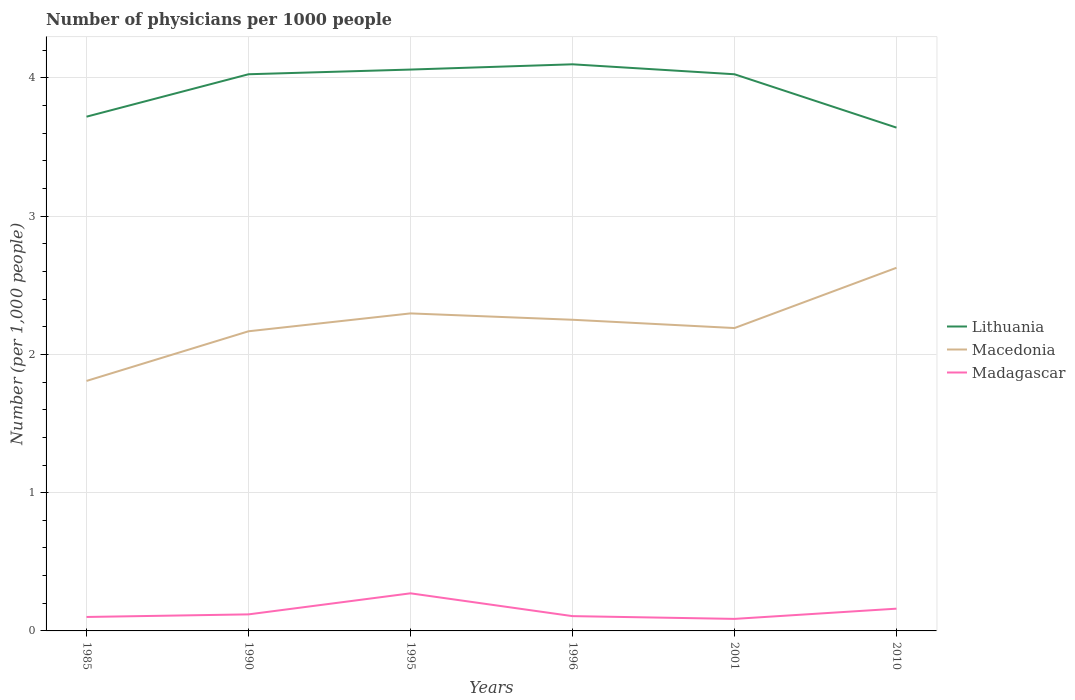Is the number of lines equal to the number of legend labels?
Ensure brevity in your answer.  Yes. Across all years, what is the maximum number of physicians in Macedonia?
Ensure brevity in your answer.  1.81. In which year was the number of physicians in Lithuania maximum?
Provide a succinct answer. 2010. What is the total number of physicians in Lithuania in the graph?
Give a very brief answer. -0.07. What is the difference between the highest and the second highest number of physicians in Macedonia?
Provide a short and direct response. 0.82. What is the difference between two consecutive major ticks on the Y-axis?
Your response must be concise. 1. Are the values on the major ticks of Y-axis written in scientific E-notation?
Your response must be concise. No. Does the graph contain grids?
Ensure brevity in your answer.  Yes. Where does the legend appear in the graph?
Your answer should be very brief. Center right. What is the title of the graph?
Your answer should be compact. Number of physicians per 1000 people. What is the label or title of the Y-axis?
Keep it short and to the point. Number (per 1,0 people). What is the Number (per 1,000 people) in Lithuania in 1985?
Offer a very short reply. 3.72. What is the Number (per 1,000 people) in Macedonia in 1985?
Provide a short and direct response. 1.81. What is the Number (per 1,000 people) in Madagascar in 1985?
Keep it short and to the point. 0.1. What is the Number (per 1,000 people) in Lithuania in 1990?
Make the answer very short. 4.03. What is the Number (per 1,000 people) in Macedonia in 1990?
Ensure brevity in your answer.  2.17. What is the Number (per 1,000 people) of Madagascar in 1990?
Keep it short and to the point. 0.12. What is the Number (per 1,000 people) of Lithuania in 1995?
Offer a terse response. 4.06. What is the Number (per 1,000 people) in Macedonia in 1995?
Your answer should be very brief. 2.3. What is the Number (per 1,000 people) in Madagascar in 1995?
Offer a very short reply. 0.27. What is the Number (per 1,000 people) in Lithuania in 1996?
Make the answer very short. 4.1. What is the Number (per 1,000 people) in Macedonia in 1996?
Give a very brief answer. 2.25. What is the Number (per 1,000 people) of Madagascar in 1996?
Offer a terse response. 0.11. What is the Number (per 1,000 people) of Lithuania in 2001?
Give a very brief answer. 4.03. What is the Number (per 1,000 people) of Macedonia in 2001?
Your answer should be compact. 2.19. What is the Number (per 1,000 people) of Madagascar in 2001?
Keep it short and to the point. 0.09. What is the Number (per 1,000 people) in Lithuania in 2010?
Keep it short and to the point. 3.64. What is the Number (per 1,000 people) in Macedonia in 2010?
Your response must be concise. 2.63. What is the Number (per 1,000 people) in Madagascar in 2010?
Keep it short and to the point. 0.16. Across all years, what is the maximum Number (per 1,000 people) of Lithuania?
Make the answer very short. 4.1. Across all years, what is the maximum Number (per 1,000 people) in Macedonia?
Make the answer very short. 2.63. Across all years, what is the maximum Number (per 1,000 people) in Madagascar?
Offer a very short reply. 0.27. Across all years, what is the minimum Number (per 1,000 people) of Lithuania?
Ensure brevity in your answer.  3.64. Across all years, what is the minimum Number (per 1,000 people) of Macedonia?
Your response must be concise. 1.81. Across all years, what is the minimum Number (per 1,000 people) of Madagascar?
Keep it short and to the point. 0.09. What is the total Number (per 1,000 people) in Lithuania in the graph?
Your response must be concise. 23.58. What is the total Number (per 1,000 people) of Macedonia in the graph?
Your answer should be very brief. 13.34. What is the total Number (per 1,000 people) of Madagascar in the graph?
Your answer should be very brief. 0.85. What is the difference between the Number (per 1,000 people) of Lithuania in 1985 and that in 1990?
Your answer should be very brief. -0.31. What is the difference between the Number (per 1,000 people) of Macedonia in 1985 and that in 1990?
Offer a terse response. -0.36. What is the difference between the Number (per 1,000 people) of Madagascar in 1985 and that in 1990?
Provide a succinct answer. -0.02. What is the difference between the Number (per 1,000 people) in Lithuania in 1985 and that in 1995?
Make the answer very short. -0.34. What is the difference between the Number (per 1,000 people) of Macedonia in 1985 and that in 1995?
Provide a short and direct response. -0.49. What is the difference between the Number (per 1,000 people) in Madagascar in 1985 and that in 1995?
Ensure brevity in your answer.  -0.17. What is the difference between the Number (per 1,000 people) of Lithuania in 1985 and that in 1996?
Ensure brevity in your answer.  -0.38. What is the difference between the Number (per 1,000 people) of Macedonia in 1985 and that in 1996?
Your response must be concise. -0.44. What is the difference between the Number (per 1,000 people) of Madagascar in 1985 and that in 1996?
Give a very brief answer. -0.01. What is the difference between the Number (per 1,000 people) in Lithuania in 1985 and that in 2001?
Your answer should be compact. -0.31. What is the difference between the Number (per 1,000 people) of Macedonia in 1985 and that in 2001?
Your answer should be compact. -0.38. What is the difference between the Number (per 1,000 people) of Madagascar in 1985 and that in 2001?
Your answer should be compact. 0.01. What is the difference between the Number (per 1,000 people) in Lithuania in 1985 and that in 2010?
Make the answer very short. 0.08. What is the difference between the Number (per 1,000 people) of Macedonia in 1985 and that in 2010?
Your answer should be compact. -0.82. What is the difference between the Number (per 1,000 people) of Madagascar in 1985 and that in 2010?
Ensure brevity in your answer.  -0.06. What is the difference between the Number (per 1,000 people) in Lithuania in 1990 and that in 1995?
Ensure brevity in your answer.  -0.03. What is the difference between the Number (per 1,000 people) of Macedonia in 1990 and that in 1995?
Ensure brevity in your answer.  -0.13. What is the difference between the Number (per 1,000 people) in Madagascar in 1990 and that in 1995?
Make the answer very short. -0.15. What is the difference between the Number (per 1,000 people) in Lithuania in 1990 and that in 1996?
Offer a very short reply. -0.07. What is the difference between the Number (per 1,000 people) in Macedonia in 1990 and that in 1996?
Offer a terse response. -0.08. What is the difference between the Number (per 1,000 people) in Madagascar in 1990 and that in 1996?
Your answer should be compact. 0.01. What is the difference between the Number (per 1,000 people) of Macedonia in 1990 and that in 2001?
Keep it short and to the point. -0.02. What is the difference between the Number (per 1,000 people) in Madagascar in 1990 and that in 2001?
Provide a short and direct response. 0.03. What is the difference between the Number (per 1,000 people) in Lithuania in 1990 and that in 2010?
Your answer should be very brief. 0.39. What is the difference between the Number (per 1,000 people) of Macedonia in 1990 and that in 2010?
Your answer should be compact. -0.46. What is the difference between the Number (per 1,000 people) of Madagascar in 1990 and that in 2010?
Give a very brief answer. -0.04. What is the difference between the Number (per 1,000 people) in Lithuania in 1995 and that in 1996?
Keep it short and to the point. -0.04. What is the difference between the Number (per 1,000 people) of Macedonia in 1995 and that in 1996?
Make the answer very short. 0.05. What is the difference between the Number (per 1,000 people) in Madagascar in 1995 and that in 1996?
Keep it short and to the point. 0.17. What is the difference between the Number (per 1,000 people) in Lithuania in 1995 and that in 2001?
Offer a very short reply. 0.03. What is the difference between the Number (per 1,000 people) in Macedonia in 1995 and that in 2001?
Make the answer very short. 0.11. What is the difference between the Number (per 1,000 people) in Madagascar in 1995 and that in 2001?
Make the answer very short. 0.18. What is the difference between the Number (per 1,000 people) in Lithuania in 1995 and that in 2010?
Give a very brief answer. 0.42. What is the difference between the Number (per 1,000 people) of Macedonia in 1995 and that in 2010?
Keep it short and to the point. -0.33. What is the difference between the Number (per 1,000 people) in Madagascar in 1995 and that in 2010?
Make the answer very short. 0.11. What is the difference between the Number (per 1,000 people) of Lithuania in 1996 and that in 2001?
Make the answer very short. 0.07. What is the difference between the Number (per 1,000 people) of Macedonia in 1996 and that in 2001?
Ensure brevity in your answer.  0.06. What is the difference between the Number (per 1,000 people) in Lithuania in 1996 and that in 2010?
Your answer should be compact. 0.46. What is the difference between the Number (per 1,000 people) of Macedonia in 1996 and that in 2010?
Offer a terse response. -0.38. What is the difference between the Number (per 1,000 people) in Madagascar in 1996 and that in 2010?
Offer a terse response. -0.05. What is the difference between the Number (per 1,000 people) in Lithuania in 2001 and that in 2010?
Give a very brief answer. 0.39. What is the difference between the Number (per 1,000 people) in Macedonia in 2001 and that in 2010?
Give a very brief answer. -0.44. What is the difference between the Number (per 1,000 people) in Madagascar in 2001 and that in 2010?
Ensure brevity in your answer.  -0.07. What is the difference between the Number (per 1,000 people) in Lithuania in 1985 and the Number (per 1,000 people) in Macedonia in 1990?
Provide a succinct answer. 1.55. What is the difference between the Number (per 1,000 people) of Lithuania in 1985 and the Number (per 1,000 people) of Madagascar in 1990?
Ensure brevity in your answer.  3.6. What is the difference between the Number (per 1,000 people) of Macedonia in 1985 and the Number (per 1,000 people) of Madagascar in 1990?
Provide a succinct answer. 1.69. What is the difference between the Number (per 1,000 people) of Lithuania in 1985 and the Number (per 1,000 people) of Macedonia in 1995?
Provide a succinct answer. 1.42. What is the difference between the Number (per 1,000 people) of Lithuania in 1985 and the Number (per 1,000 people) of Madagascar in 1995?
Your response must be concise. 3.45. What is the difference between the Number (per 1,000 people) of Macedonia in 1985 and the Number (per 1,000 people) of Madagascar in 1995?
Your answer should be very brief. 1.54. What is the difference between the Number (per 1,000 people) of Lithuania in 1985 and the Number (per 1,000 people) of Macedonia in 1996?
Ensure brevity in your answer.  1.47. What is the difference between the Number (per 1,000 people) in Lithuania in 1985 and the Number (per 1,000 people) in Madagascar in 1996?
Keep it short and to the point. 3.61. What is the difference between the Number (per 1,000 people) in Macedonia in 1985 and the Number (per 1,000 people) in Madagascar in 1996?
Give a very brief answer. 1.7. What is the difference between the Number (per 1,000 people) of Lithuania in 1985 and the Number (per 1,000 people) of Macedonia in 2001?
Offer a very short reply. 1.53. What is the difference between the Number (per 1,000 people) of Lithuania in 1985 and the Number (per 1,000 people) of Madagascar in 2001?
Make the answer very short. 3.63. What is the difference between the Number (per 1,000 people) in Macedonia in 1985 and the Number (per 1,000 people) in Madagascar in 2001?
Offer a very short reply. 1.72. What is the difference between the Number (per 1,000 people) in Lithuania in 1985 and the Number (per 1,000 people) in Macedonia in 2010?
Your response must be concise. 1.09. What is the difference between the Number (per 1,000 people) in Lithuania in 1985 and the Number (per 1,000 people) in Madagascar in 2010?
Give a very brief answer. 3.56. What is the difference between the Number (per 1,000 people) in Macedonia in 1985 and the Number (per 1,000 people) in Madagascar in 2010?
Keep it short and to the point. 1.65. What is the difference between the Number (per 1,000 people) in Lithuania in 1990 and the Number (per 1,000 people) in Macedonia in 1995?
Offer a terse response. 1.73. What is the difference between the Number (per 1,000 people) of Lithuania in 1990 and the Number (per 1,000 people) of Madagascar in 1995?
Provide a short and direct response. 3.75. What is the difference between the Number (per 1,000 people) of Macedonia in 1990 and the Number (per 1,000 people) of Madagascar in 1995?
Your response must be concise. 1.9. What is the difference between the Number (per 1,000 people) in Lithuania in 1990 and the Number (per 1,000 people) in Macedonia in 1996?
Offer a very short reply. 1.78. What is the difference between the Number (per 1,000 people) in Lithuania in 1990 and the Number (per 1,000 people) in Madagascar in 1996?
Ensure brevity in your answer.  3.92. What is the difference between the Number (per 1,000 people) in Macedonia in 1990 and the Number (per 1,000 people) in Madagascar in 1996?
Make the answer very short. 2.06. What is the difference between the Number (per 1,000 people) in Lithuania in 1990 and the Number (per 1,000 people) in Macedonia in 2001?
Keep it short and to the point. 1.84. What is the difference between the Number (per 1,000 people) of Lithuania in 1990 and the Number (per 1,000 people) of Madagascar in 2001?
Give a very brief answer. 3.94. What is the difference between the Number (per 1,000 people) in Macedonia in 1990 and the Number (per 1,000 people) in Madagascar in 2001?
Keep it short and to the point. 2.08. What is the difference between the Number (per 1,000 people) in Lithuania in 1990 and the Number (per 1,000 people) in Madagascar in 2010?
Offer a very short reply. 3.87. What is the difference between the Number (per 1,000 people) in Macedonia in 1990 and the Number (per 1,000 people) in Madagascar in 2010?
Provide a succinct answer. 2.01. What is the difference between the Number (per 1,000 people) of Lithuania in 1995 and the Number (per 1,000 people) of Macedonia in 1996?
Give a very brief answer. 1.81. What is the difference between the Number (per 1,000 people) in Lithuania in 1995 and the Number (per 1,000 people) in Madagascar in 1996?
Keep it short and to the point. 3.95. What is the difference between the Number (per 1,000 people) of Macedonia in 1995 and the Number (per 1,000 people) of Madagascar in 1996?
Your answer should be very brief. 2.19. What is the difference between the Number (per 1,000 people) of Lithuania in 1995 and the Number (per 1,000 people) of Macedonia in 2001?
Keep it short and to the point. 1.87. What is the difference between the Number (per 1,000 people) in Lithuania in 1995 and the Number (per 1,000 people) in Madagascar in 2001?
Ensure brevity in your answer.  3.97. What is the difference between the Number (per 1,000 people) of Macedonia in 1995 and the Number (per 1,000 people) of Madagascar in 2001?
Offer a terse response. 2.21. What is the difference between the Number (per 1,000 people) of Lithuania in 1995 and the Number (per 1,000 people) of Macedonia in 2010?
Your response must be concise. 1.43. What is the difference between the Number (per 1,000 people) of Macedonia in 1995 and the Number (per 1,000 people) of Madagascar in 2010?
Offer a very short reply. 2.14. What is the difference between the Number (per 1,000 people) of Lithuania in 1996 and the Number (per 1,000 people) of Macedonia in 2001?
Make the answer very short. 1.91. What is the difference between the Number (per 1,000 people) of Lithuania in 1996 and the Number (per 1,000 people) of Madagascar in 2001?
Your answer should be compact. 4.01. What is the difference between the Number (per 1,000 people) in Macedonia in 1996 and the Number (per 1,000 people) in Madagascar in 2001?
Give a very brief answer. 2.16. What is the difference between the Number (per 1,000 people) in Lithuania in 1996 and the Number (per 1,000 people) in Macedonia in 2010?
Offer a very short reply. 1.47. What is the difference between the Number (per 1,000 people) in Lithuania in 1996 and the Number (per 1,000 people) in Madagascar in 2010?
Offer a terse response. 3.94. What is the difference between the Number (per 1,000 people) in Macedonia in 1996 and the Number (per 1,000 people) in Madagascar in 2010?
Make the answer very short. 2.09. What is the difference between the Number (per 1,000 people) in Lithuania in 2001 and the Number (per 1,000 people) in Macedonia in 2010?
Your answer should be very brief. 1.4. What is the difference between the Number (per 1,000 people) in Lithuania in 2001 and the Number (per 1,000 people) in Madagascar in 2010?
Keep it short and to the point. 3.87. What is the difference between the Number (per 1,000 people) in Macedonia in 2001 and the Number (per 1,000 people) in Madagascar in 2010?
Offer a very short reply. 2.03. What is the average Number (per 1,000 people) in Lithuania per year?
Your answer should be very brief. 3.93. What is the average Number (per 1,000 people) in Macedonia per year?
Offer a very short reply. 2.22. What is the average Number (per 1,000 people) in Madagascar per year?
Give a very brief answer. 0.14. In the year 1985, what is the difference between the Number (per 1,000 people) of Lithuania and Number (per 1,000 people) of Macedonia?
Your response must be concise. 1.91. In the year 1985, what is the difference between the Number (per 1,000 people) of Lithuania and Number (per 1,000 people) of Madagascar?
Your answer should be very brief. 3.62. In the year 1985, what is the difference between the Number (per 1,000 people) of Macedonia and Number (per 1,000 people) of Madagascar?
Your answer should be compact. 1.71. In the year 1990, what is the difference between the Number (per 1,000 people) in Lithuania and Number (per 1,000 people) in Macedonia?
Your answer should be compact. 1.86. In the year 1990, what is the difference between the Number (per 1,000 people) in Lithuania and Number (per 1,000 people) in Madagascar?
Provide a short and direct response. 3.91. In the year 1990, what is the difference between the Number (per 1,000 people) in Macedonia and Number (per 1,000 people) in Madagascar?
Your response must be concise. 2.05. In the year 1995, what is the difference between the Number (per 1,000 people) of Lithuania and Number (per 1,000 people) of Macedonia?
Provide a short and direct response. 1.76. In the year 1995, what is the difference between the Number (per 1,000 people) of Lithuania and Number (per 1,000 people) of Madagascar?
Keep it short and to the point. 3.79. In the year 1995, what is the difference between the Number (per 1,000 people) of Macedonia and Number (per 1,000 people) of Madagascar?
Your response must be concise. 2.02. In the year 1996, what is the difference between the Number (per 1,000 people) in Lithuania and Number (per 1,000 people) in Macedonia?
Offer a terse response. 1.85. In the year 1996, what is the difference between the Number (per 1,000 people) of Lithuania and Number (per 1,000 people) of Madagascar?
Offer a very short reply. 3.99. In the year 1996, what is the difference between the Number (per 1,000 people) of Macedonia and Number (per 1,000 people) of Madagascar?
Ensure brevity in your answer.  2.14. In the year 2001, what is the difference between the Number (per 1,000 people) in Lithuania and Number (per 1,000 people) in Macedonia?
Your answer should be compact. 1.84. In the year 2001, what is the difference between the Number (per 1,000 people) of Lithuania and Number (per 1,000 people) of Madagascar?
Your answer should be compact. 3.94. In the year 2001, what is the difference between the Number (per 1,000 people) in Macedonia and Number (per 1,000 people) in Madagascar?
Make the answer very short. 2.1. In the year 2010, what is the difference between the Number (per 1,000 people) of Lithuania and Number (per 1,000 people) of Macedonia?
Offer a terse response. 1.01. In the year 2010, what is the difference between the Number (per 1,000 people) in Lithuania and Number (per 1,000 people) in Madagascar?
Offer a terse response. 3.48. In the year 2010, what is the difference between the Number (per 1,000 people) of Macedonia and Number (per 1,000 people) of Madagascar?
Offer a terse response. 2.47. What is the ratio of the Number (per 1,000 people) of Lithuania in 1985 to that in 1990?
Offer a very short reply. 0.92. What is the ratio of the Number (per 1,000 people) in Macedonia in 1985 to that in 1990?
Give a very brief answer. 0.83. What is the ratio of the Number (per 1,000 people) in Madagascar in 1985 to that in 1990?
Offer a very short reply. 0.84. What is the ratio of the Number (per 1,000 people) of Lithuania in 1985 to that in 1995?
Your answer should be very brief. 0.92. What is the ratio of the Number (per 1,000 people) in Macedonia in 1985 to that in 1995?
Your response must be concise. 0.79. What is the ratio of the Number (per 1,000 people) of Madagascar in 1985 to that in 1995?
Provide a short and direct response. 0.37. What is the ratio of the Number (per 1,000 people) of Lithuania in 1985 to that in 1996?
Provide a succinct answer. 0.91. What is the ratio of the Number (per 1,000 people) in Macedonia in 1985 to that in 1996?
Give a very brief answer. 0.8. What is the ratio of the Number (per 1,000 people) of Madagascar in 1985 to that in 1996?
Make the answer very short. 0.94. What is the ratio of the Number (per 1,000 people) of Lithuania in 1985 to that in 2001?
Offer a very short reply. 0.92. What is the ratio of the Number (per 1,000 people) in Macedonia in 1985 to that in 2001?
Your answer should be very brief. 0.83. What is the ratio of the Number (per 1,000 people) in Madagascar in 1985 to that in 2001?
Keep it short and to the point. 1.16. What is the ratio of the Number (per 1,000 people) of Lithuania in 1985 to that in 2010?
Offer a very short reply. 1.02. What is the ratio of the Number (per 1,000 people) of Macedonia in 1985 to that in 2010?
Provide a succinct answer. 0.69. What is the ratio of the Number (per 1,000 people) of Madagascar in 1985 to that in 2010?
Your response must be concise. 0.63. What is the ratio of the Number (per 1,000 people) of Macedonia in 1990 to that in 1995?
Provide a succinct answer. 0.94. What is the ratio of the Number (per 1,000 people) of Madagascar in 1990 to that in 1995?
Your answer should be compact. 0.44. What is the ratio of the Number (per 1,000 people) in Lithuania in 1990 to that in 1996?
Your answer should be very brief. 0.98. What is the ratio of the Number (per 1,000 people) in Madagascar in 1990 to that in 1996?
Your answer should be very brief. 1.12. What is the ratio of the Number (per 1,000 people) of Madagascar in 1990 to that in 2001?
Provide a succinct answer. 1.38. What is the ratio of the Number (per 1,000 people) in Lithuania in 1990 to that in 2010?
Make the answer very short. 1.11. What is the ratio of the Number (per 1,000 people) in Macedonia in 1990 to that in 2010?
Ensure brevity in your answer.  0.83. What is the ratio of the Number (per 1,000 people) of Madagascar in 1990 to that in 2010?
Keep it short and to the point. 0.74. What is the ratio of the Number (per 1,000 people) of Lithuania in 1995 to that in 1996?
Offer a terse response. 0.99. What is the ratio of the Number (per 1,000 people) of Macedonia in 1995 to that in 1996?
Offer a very short reply. 1.02. What is the ratio of the Number (per 1,000 people) of Madagascar in 1995 to that in 1996?
Make the answer very short. 2.54. What is the ratio of the Number (per 1,000 people) in Lithuania in 1995 to that in 2001?
Provide a succinct answer. 1.01. What is the ratio of the Number (per 1,000 people) of Macedonia in 1995 to that in 2001?
Your answer should be compact. 1.05. What is the ratio of the Number (per 1,000 people) in Madagascar in 1995 to that in 2001?
Provide a short and direct response. 3.13. What is the ratio of the Number (per 1,000 people) in Lithuania in 1995 to that in 2010?
Your answer should be very brief. 1.12. What is the ratio of the Number (per 1,000 people) in Macedonia in 1995 to that in 2010?
Your response must be concise. 0.87. What is the ratio of the Number (per 1,000 people) of Madagascar in 1995 to that in 2010?
Keep it short and to the point. 1.69. What is the ratio of the Number (per 1,000 people) in Lithuania in 1996 to that in 2001?
Provide a short and direct response. 1.02. What is the ratio of the Number (per 1,000 people) in Macedonia in 1996 to that in 2001?
Give a very brief answer. 1.03. What is the ratio of the Number (per 1,000 people) of Madagascar in 1996 to that in 2001?
Make the answer very short. 1.23. What is the ratio of the Number (per 1,000 people) of Lithuania in 1996 to that in 2010?
Make the answer very short. 1.13. What is the ratio of the Number (per 1,000 people) of Macedonia in 1996 to that in 2010?
Give a very brief answer. 0.86. What is the ratio of the Number (per 1,000 people) of Madagascar in 1996 to that in 2010?
Provide a succinct answer. 0.66. What is the ratio of the Number (per 1,000 people) in Lithuania in 2001 to that in 2010?
Make the answer very short. 1.11. What is the ratio of the Number (per 1,000 people) of Macedonia in 2001 to that in 2010?
Offer a very short reply. 0.83. What is the ratio of the Number (per 1,000 people) in Madagascar in 2001 to that in 2010?
Ensure brevity in your answer.  0.54. What is the difference between the highest and the second highest Number (per 1,000 people) of Lithuania?
Your answer should be very brief. 0.04. What is the difference between the highest and the second highest Number (per 1,000 people) in Macedonia?
Offer a terse response. 0.33. What is the difference between the highest and the second highest Number (per 1,000 people) of Madagascar?
Your answer should be compact. 0.11. What is the difference between the highest and the lowest Number (per 1,000 people) of Lithuania?
Offer a terse response. 0.46. What is the difference between the highest and the lowest Number (per 1,000 people) in Macedonia?
Offer a terse response. 0.82. What is the difference between the highest and the lowest Number (per 1,000 people) in Madagascar?
Give a very brief answer. 0.18. 